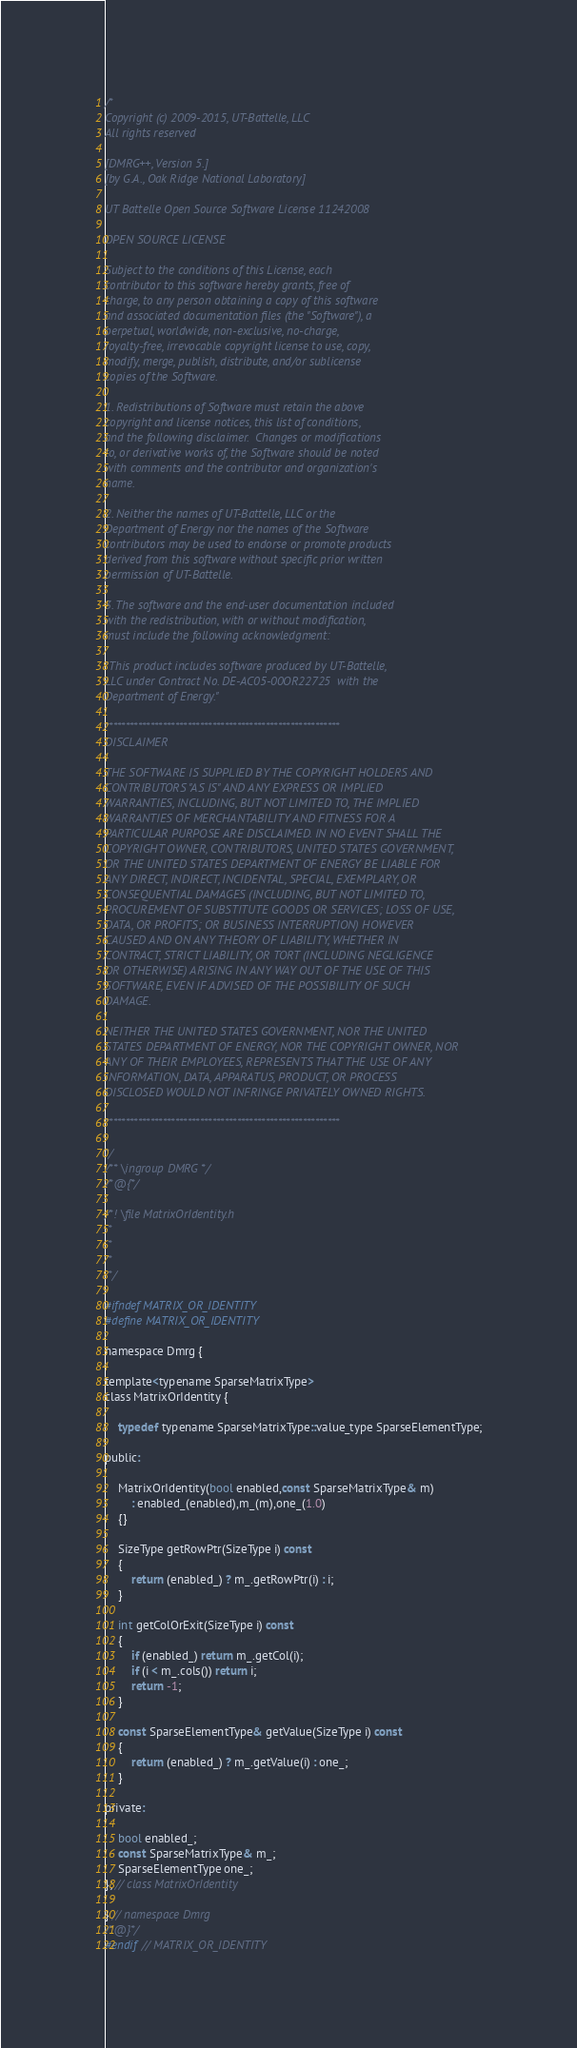<code> <loc_0><loc_0><loc_500><loc_500><_C_>/*
Copyright (c) 2009-2015, UT-Battelle, LLC
All rights reserved

[DMRG++, Version 5.]
[by G.A., Oak Ridge National Laboratory]

UT Battelle Open Source Software License 11242008

OPEN SOURCE LICENSE

Subject to the conditions of this License, each
contributor to this software hereby grants, free of
charge, to any person obtaining a copy of this software
and associated documentation files (the "Software"), a
perpetual, worldwide, non-exclusive, no-charge,
royalty-free, irrevocable copyright license to use, copy,
modify, merge, publish, distribute, and/or sublicense
copies of the Software.

1. Redistributions of Software must retain the above
copyright and license notices, this list of conditions,
and the following disclaimer.  Changes or modifications
to, or derivative works of, the Software should be noted
with comments and the contributor and organization's
name.

2. Neither the names of UT-Battelle, LLC or the
Department of Energy nor the names of the Software
contributors may be used to endorse or promote products
derived from this software without specific prior written
permission of UT-Battelle.

3. The software and the end-user documentation included
with the redistribution, with or without modification,
must include the following acknowledgment:

"This product includes software produced by UT-Battelle,
LLC under Contract No. DE-AC05-00OR22725  with the
Department of Energy."

*********************************************************
DISCLAIMER

THE SOFTWARE IS SUPPLIED BY THE COPYRIGHT HOLDERS AND
CONTRIBUTORS "AS IS" AND ANY EXPRESS OR IMPLIED
WARRANTIES, INCLUDING, BUT NOT LIMITED TO, THE IMPLIED
WARRANTIES OF MERCHANTABILITY AND FITNESS FOR A
PARTICULAR PURPOSE ARE DISCLAIMED. IN NO EVENT SHALL THE
COPYRIGHT OWNER, CONTRIBUTORS, UNITED STATES GOVERNMENT,
OR THE UNITED STATES DEPARTMENT OF ENERGY BE LIABLE FOR
ANY DIRECT, INDIRECT, INCIDENTAL, SPECIAL, EXEMPLARY, OR
CONSEQUENTIAL DAMAGES (INCLUDING, BUT NOT LIMITED TO,
PROCUREMENT OF SUBSTITUTE GOODS OR SERVICES; LOSS OF USE,
DATA, OR PROFITS; OR BUSINESS INTERRUPTION) HOWEVER
CAUSED AND ON ANY THEORY OF LIABILITY, WHETHER IN
CONTRACT, STRICT LIABILITY, OR TORT (INCLUDING NEGLIGENCE
OR OTHERWISE) ARISING IN ANY WAY OUT OF THE USE OF THIS
SOFTWARE, EVEN IF ADVISED OF THE POSSIBILITY OF SUCH
DAMAGE.

NEITHER THE UNITED STATES GOVERNMENT, NOR THE UNITED
STATES DEPARTMENT OF ENERGY, NOR THE COPYRIGHT OWNER, NOR
ANY OF THEIR EMPLOYEES, REPRESENTS THAT THE USE OF ANY
INFORMATION, DATA, APPARATUS, PRODUCT, OR PROCESS
DISCLOSED WOULD NOT INFRINGE PRIVATELY OWNED RIGHTS.

*********************************************************

*/
/** \ingroup DMRG */
/*@{*/

/*! \file MatrixOrIdentity.h
 *
 *
 *
 */

#ifndef MATRIX_OR_IDENTITY
#define MATRIX_OR_IDENTITY

namespace Dmrg {

template<typename SparseMatrixType>
class MatrixOrIdentity {

	typedef typename SparseMatrixType::value_type SparseElementType;

public:

	MatrixOrIdentity(bool enabled,const SparseMatrixType& m)
	    : enabled_(enabled),m_(m),one_(1.0)
	{}

	SizeType getRowPtr(SizeType i) const
	{
		return (enabled_) ? m_.getRowPtr(i) : i;
	}

	int getColOrExit(SizeType i) const
	{
		if (enabled_) return m_.getCol(i);
		if (i < m_.cols()) return i;
		return -1;
	}

	const SparseElementType& getValue(SizeType i) const
	{
		return (enabled_) ? m_.getValue(i) : one_;
	}

private:

	bool enabled_;
	const SparseMatrixType& m_;
	SparseElementType one_;
}; // class MatrixOrIdentity

} // namespace Dmrg
/*@}*/
#endif // MATRIX_OR_IDENTITY

</code> 